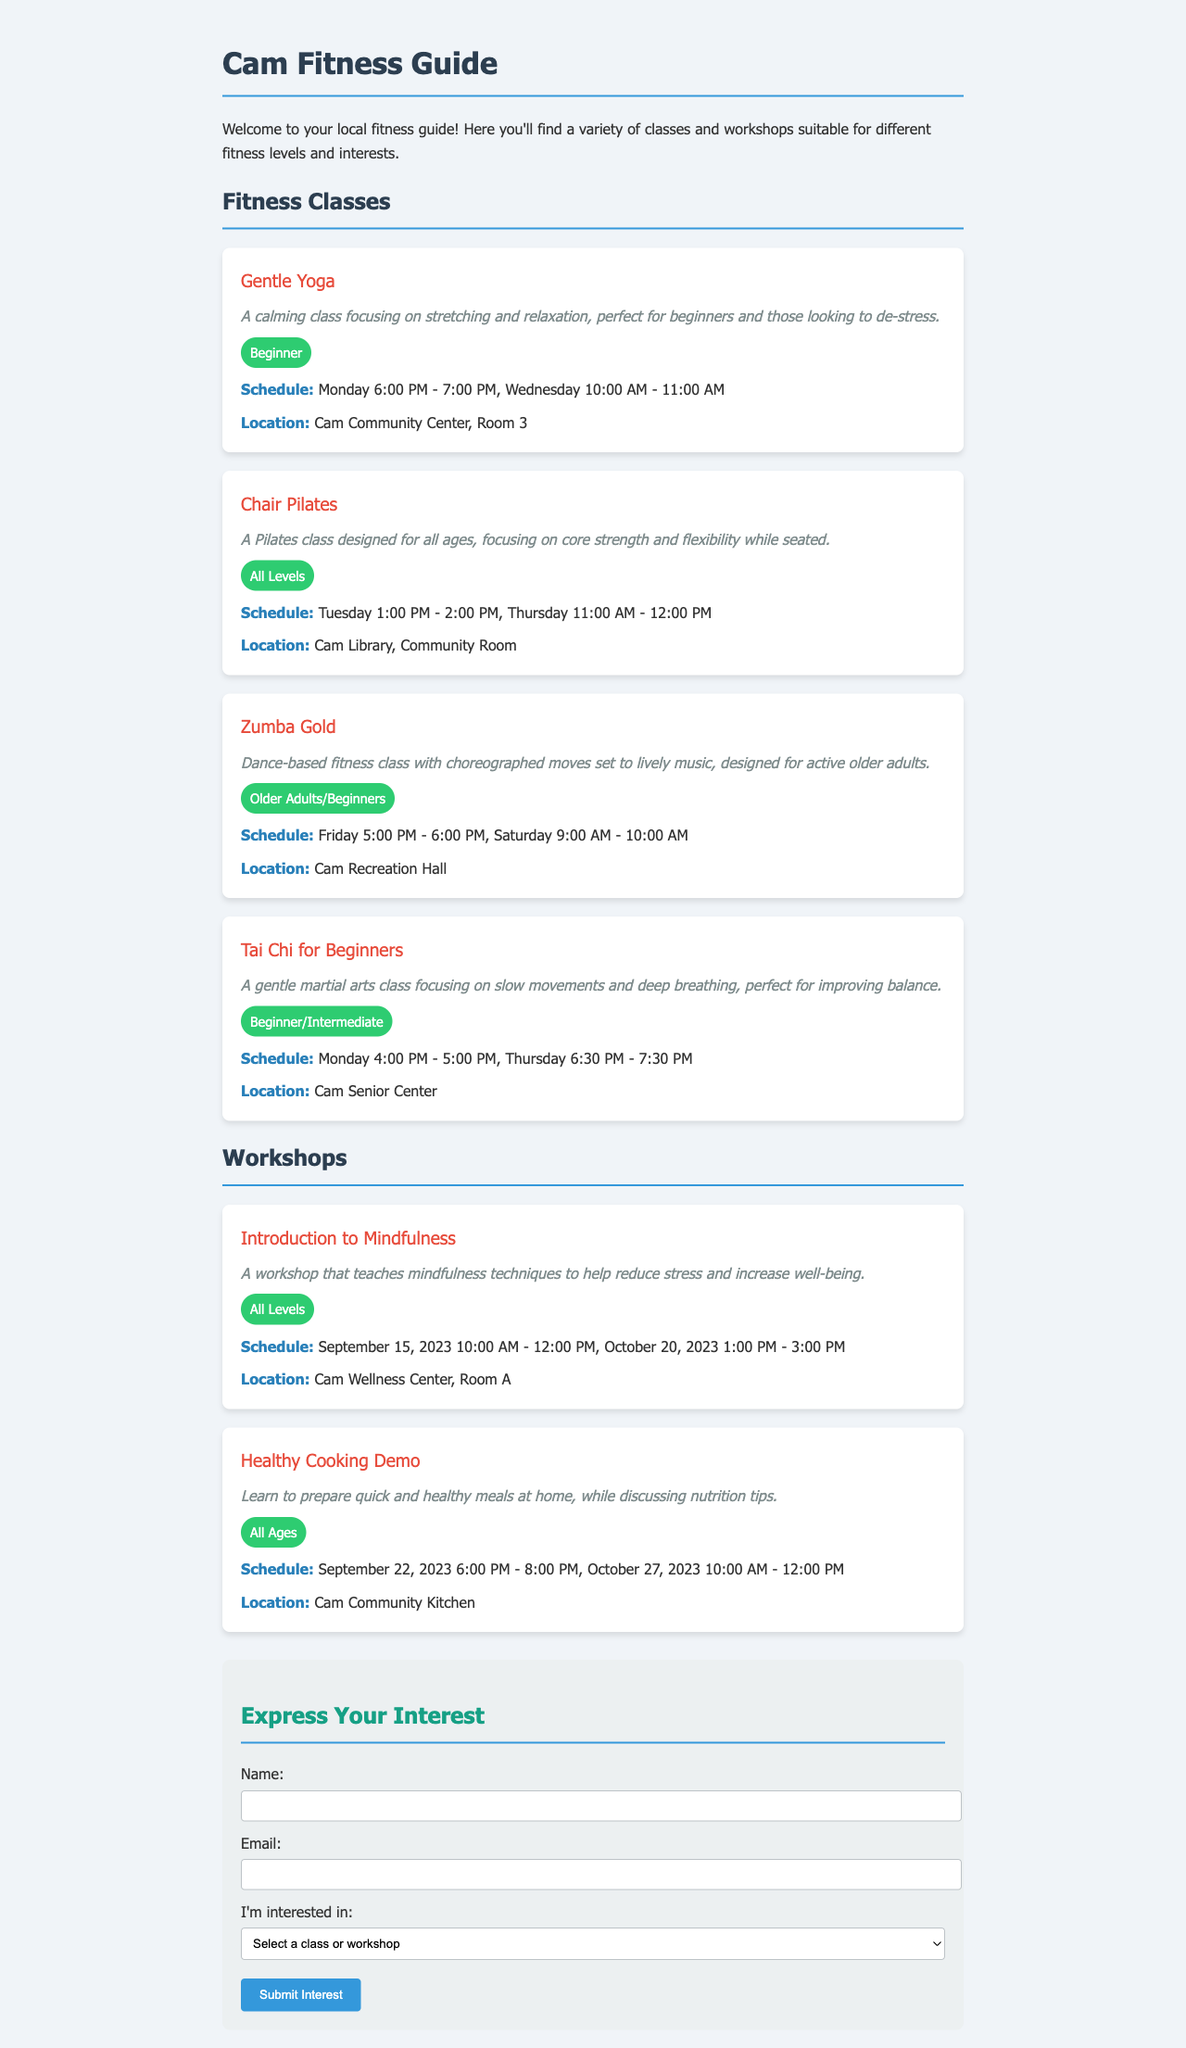What is the schedule for Gentle Yoga? The schedule for Gentle Yoga is detailed in the class section of the document stating it is on Monday 6:00 PM - 7:00 PM and Wednesday 10:00 AM - 11:00 AM.
Answer: Monday 6:00 PM - 7:00 PM, Wednesday 10:00 AM - 11:00 AM Where is the Chair Pilates class held? The location for the Chair Pilates class is specified in the document as Cam Library, Community Room.
Answer: Cam Library, Community Room What fitness level is Zumba Gold suitable for? The document states Zumba Gold is designed for Older Adults/Beginners, highlighting the target audience for the class.
Answer: Older Adults/Beginners When is the Introduction to Mindfulness workshop taking place? The workshop has two scheduled dates mentioned in the document: September 15, 2023, and October 20, 2023.
Answer: September 15, 2023 and October 20, 2023 What type of class is Tai Chi for Beginners? The document describes Tai Chi for Beginners as a gentle martial arts class focused on slow movements and deep breathing.
Answer: Gentle martial arts class Which class is focused on healthy cooking? The document clearly lists the Healthy Cooking Demo as the workshop centered on preparing quick and healthy meals at home.
Answer: Healthy Cooking Demo How many classes are listed under Fitness Classes? In total, there are four fitness classes detailed in the document.
Answer: Four What is the required action to express interest in a class? The document indicates that an individual must submit their interest using the provided submission form.
Answer: Submit Interest 